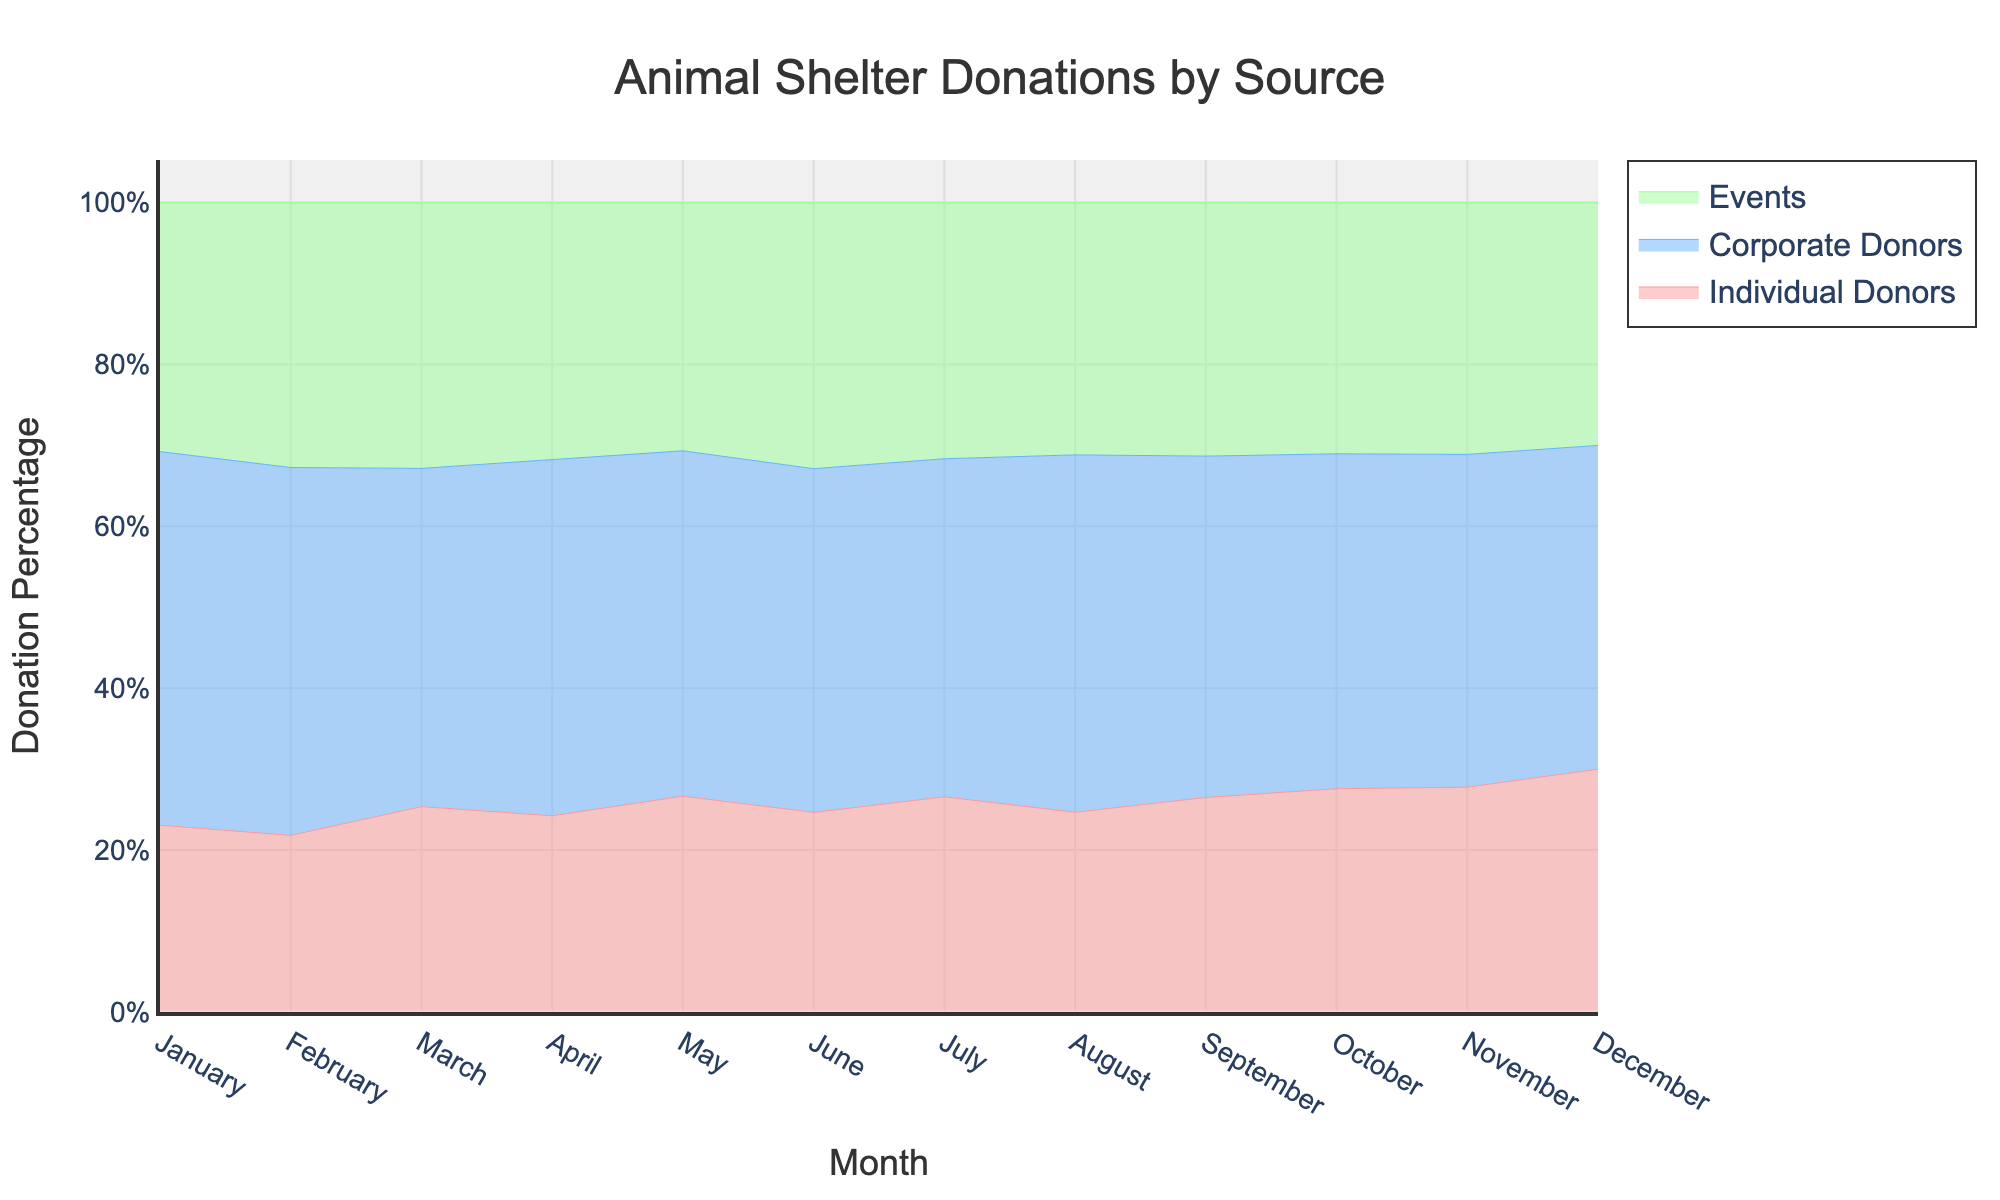What is the title of the graph? The title is generally found at the top of the graph. In this case, it is clearly stated there.
Answer: Animal Shelter Donations by Source What does the y-axis represent? The y-axis label provides this information. In the figure, the y-axis is labeled as "Donation Percentage."
Answer: Donation Percentage Which donor type had the highest donation percentage in March? By examining the stack heights in March, look for the segment with the highest position using different colors for Individual Donors, Corporate Donors, and Events. Corporate Donors' section appears highest.
Answer: Corporate Donors Which month had the highest cumulative donations from all sources? Look for the month where the total height of the stacked areas (sum of all sources) is the largest. December shows the largest cumulative height.
Answer: December By how much did the individual donors' donations increase from February to March? Examine the position and compare the height of the Individual Donors' graph between February and March. The value changes from 1200 to 1700; the difference is 1700 - 1200 = 500.
Answer: 500 In which month did event donations account for the highest percentage of total donations? This requires observing the proportion of the Events stream across all months and finding where it appears largest. March and April show substantial heights for Events, but October is particularly notable.
Answer: October Compare individual donors and corporate donors in terms of donation percentage for July. Which was higher? In July, look at the height of the Individual Donors and Corporate Donors segments and compare them. The Corporate Donors' section is higher than Individual Donors in that month.
Answer: Corporate Donors What trend can be observed in corporate donations throughout the year? Follow the Corporate Donors' color stream throughout the months to see if donations increase, decrease, or remain stable. Corporate donations show a steady increase from January to December.
Answer: Steady increase What is the average donation amount across all months for event donations? Sum the event donations for each month and divide by the number of months. Calculation: (2000 + 1800 + 2200 + 2100 + 2300 + 2400 + 2500 + 2400 + 2600 + 2700 + 2800 + 3000) / 12 = 2425.
Answer: 2425 Which month showed the smallest difference between individual donors and events donations? Calculate the differences for each month and find the smallest one. February’s difference between Individual Donors (1200) and Events (1800) is 600, the smallest difference.
Answer: February 